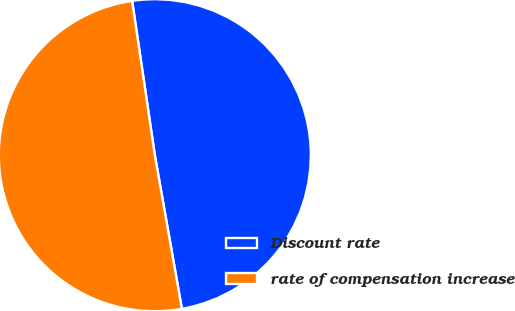Convert chart. <chart><loc_0><loc_0><loc_500><loc_500><pie_chart><fcel>Discount rate<fcel>rate of compensation increase<nl><fcel>49.55%<fcel>50.45%<nl></chart> 